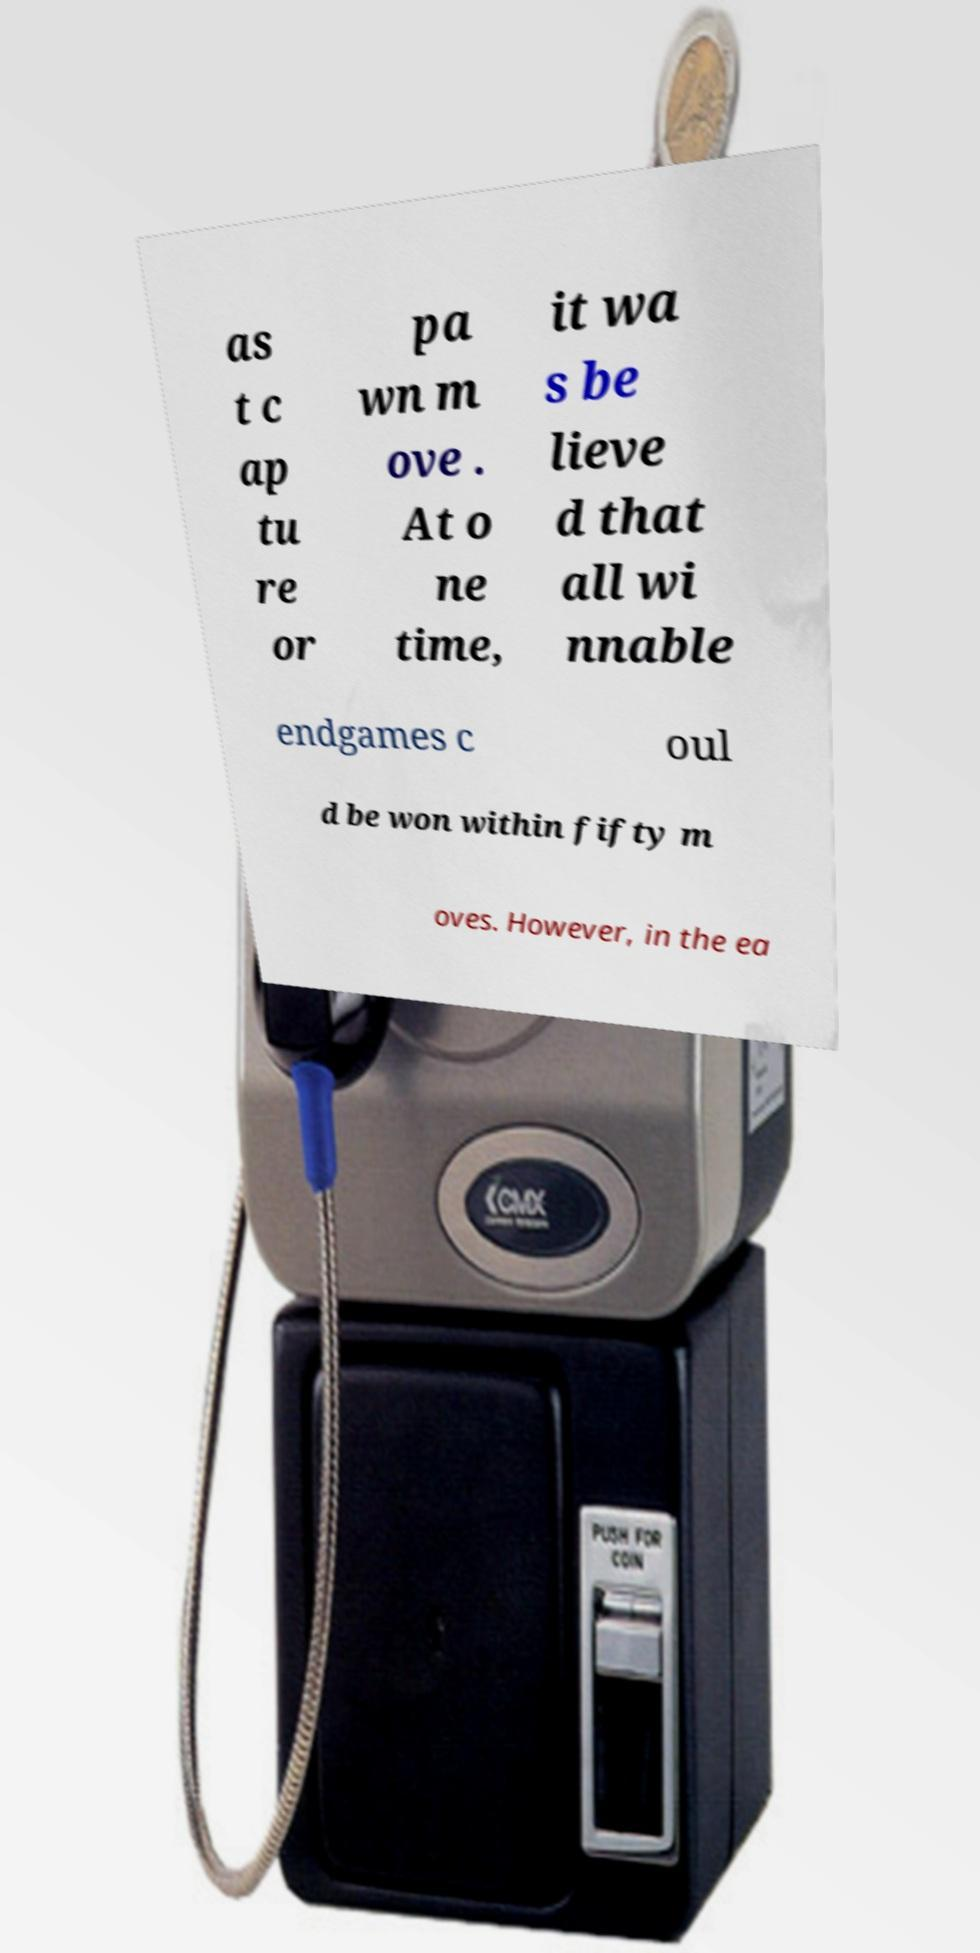Please identify and transcribe the text found in this image. as t c ap tu re or pa wn m ove . At o ne time, it wa s be lieve d that all wi nnable endgames c oul d be won within fifty m oves. However, in the ea 